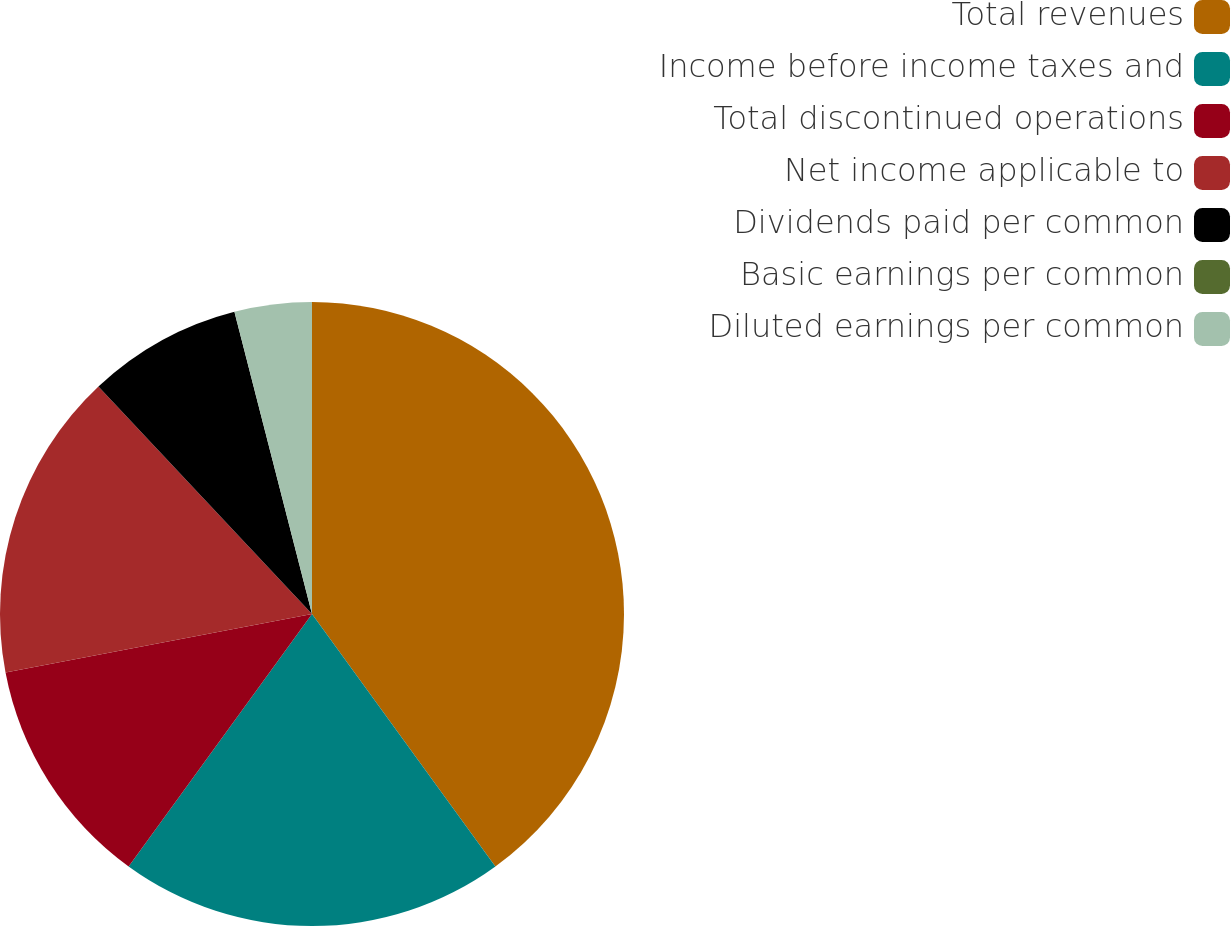Convert chart to OTSL. <chart><loc_0><loc_0><loc_500><loc_500><pie_chart><fcel>Total revenues<fcel>Income before income taxes and<fcel>Total discontinued operations<fcel>Net income applicable to<fcel>Dividends paid per common<fcel>Basic earnings per common<fcel>Diluted earnings per common<nl><fcel>40.0%<fcel>20.0%<fcel>12.0%<fcel>16.0%<fcel>8.0%<fcel>0.0%<fcel>4.0%<nl></chart> 